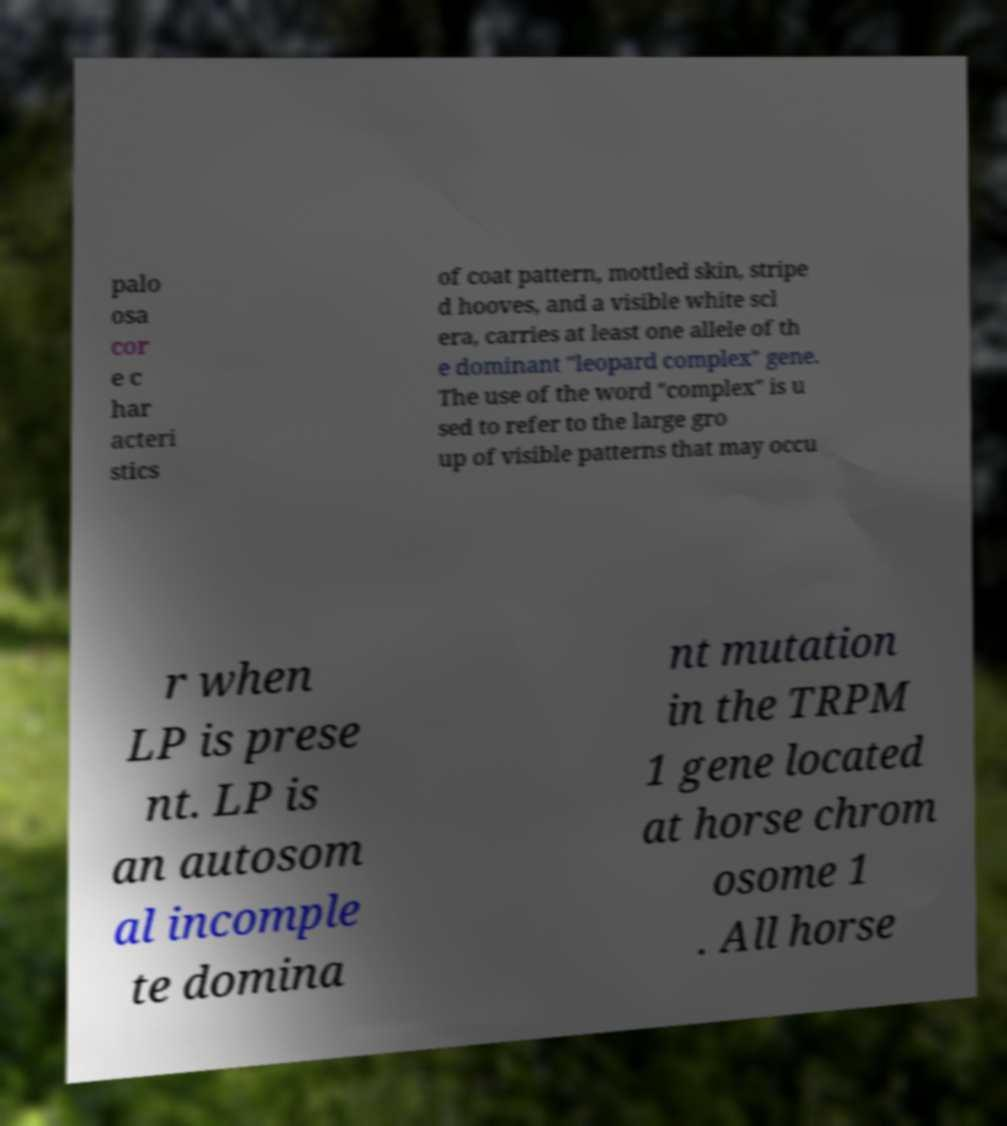Please identify and transcribe the text found in this image. palo osa cor e c har acteri stics of coat pattern, mottled skin, stripe d hooves, and a visible white scl era, carries at least one allele of th e dominant "leopard complex" gene. The use of the word "complex" is u sed to refer to the large gro up of visible patterns that may occu r when LP is prese nt. LP is an autosom al incomple te domina nt mutation in the TRPM 1 gene located at horse chrom osome 1 . All horse 